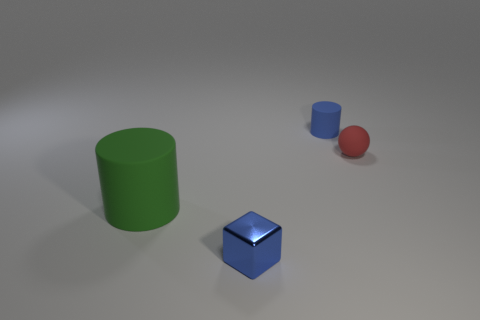Add 1 green matte cylinders. How many objects exist? 5 Subtract all cubes. How many objects are left? 3 Subtract all tiny red shiny objects. Subtract all small blue matte things. How many objects are left? 3 Add 1 large matte objects. How many large matte objects are left? 2 Add 3 green matte spheres. How many green matte spheres exist? 3 Subtract 0 red cylinders. How many objects are left? 4 